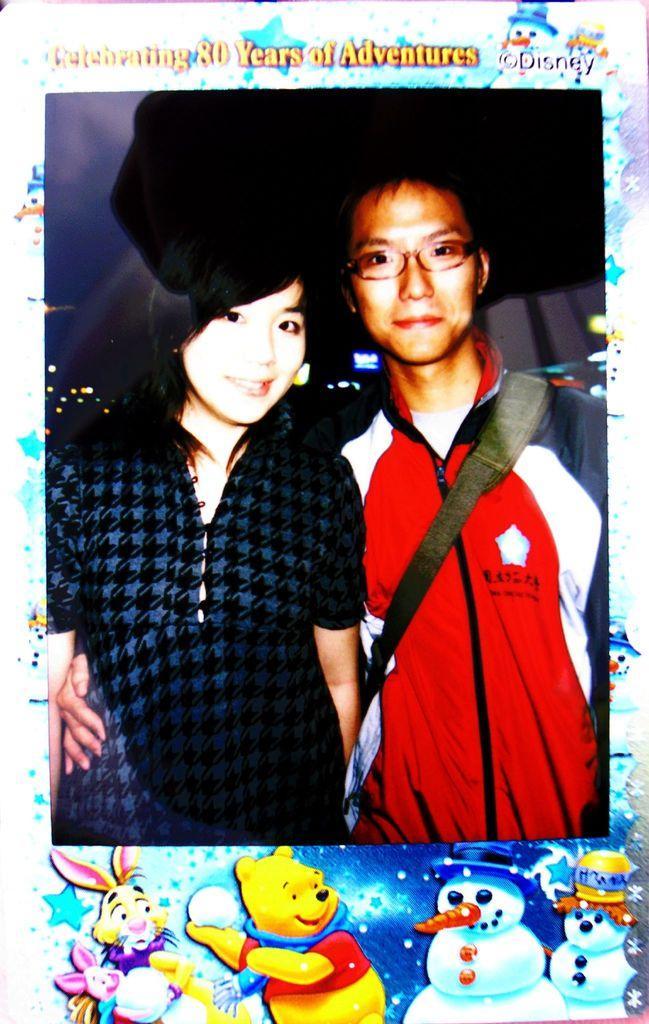In one or two sentences, can you explain what this image depicts? In this image it looks like a frame in which there is a couple. There is a man on the right side and a girl on the left side. 